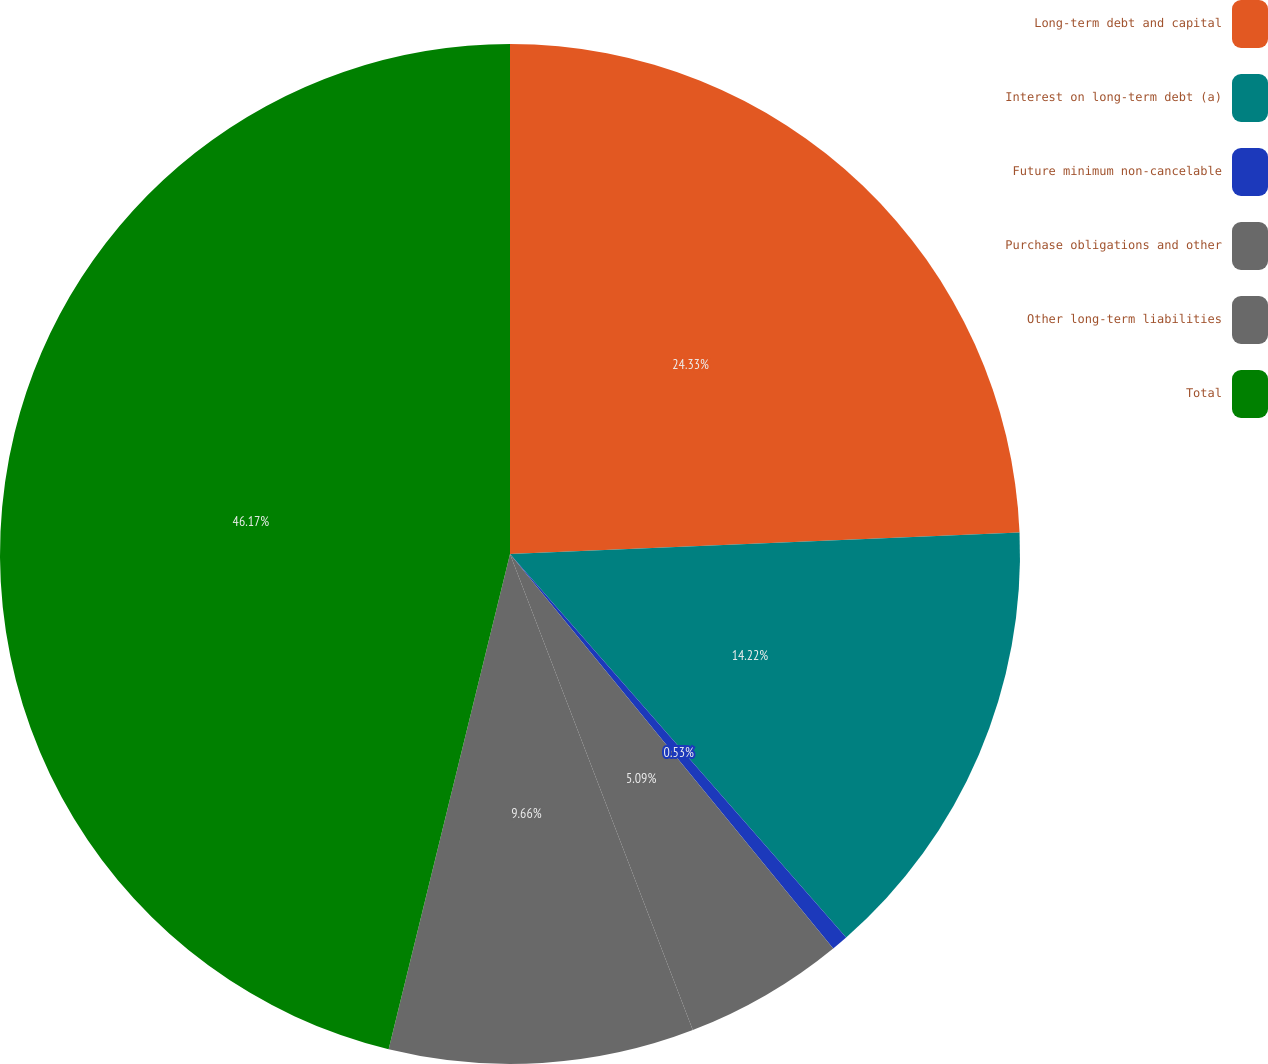<chart> <loc_0><loc_0><loc_500><loc_500><pie_chart><fcel>Long-term debt and capital<fcel>Interest on long-term debt (a)<fcel>Future minimum non-cancelable<fcel>Purchase obligations and other<fcel>Other long-term liabilities<fcel>Total<nl><fcel>24.33%<fcel>14.22%<fcel>0.53%<fcel>5.09%<fcel>9.66%<fcel>46.18%<nl></chart> 